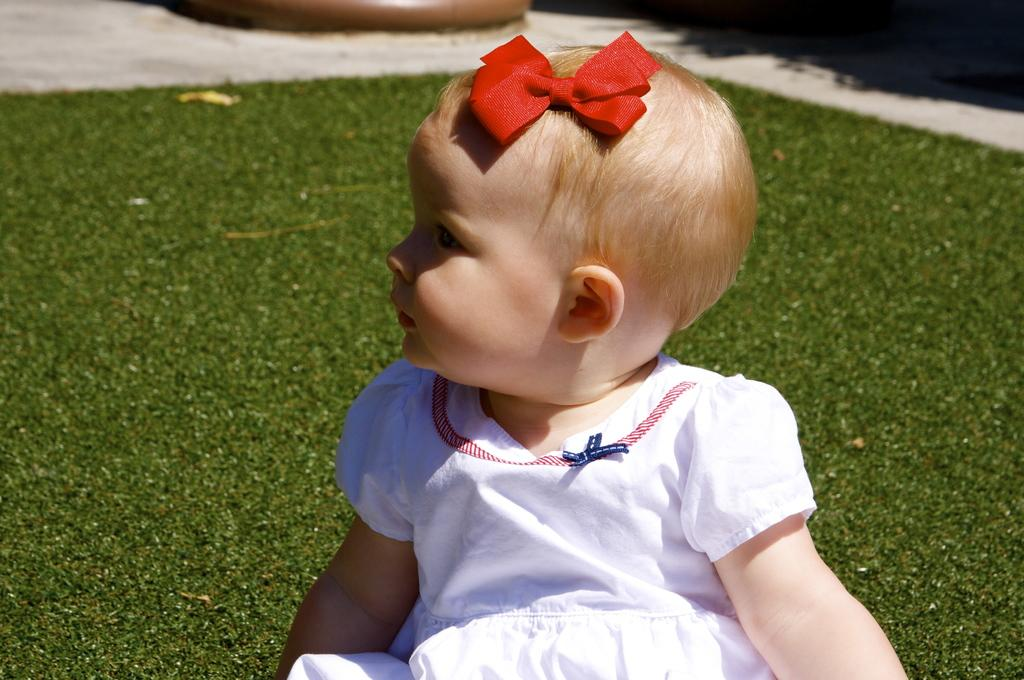What is the main subject of the picture? The main subject of the picture is a little baby. What is the baby wearing in the picture? The baby is wearing a white gown in the picture. Where is the baby sitting in the picture? The baby is sitting on the grass in the picture. What type of beast can be seen interacting with the baby in the picture? There is no beast present in the picture; the baby is sitting on the grass alone. What kind of haircut does the baby have in the picture? The provided facts do not mention the baby's haircut, so we cannot determine it from the image. 